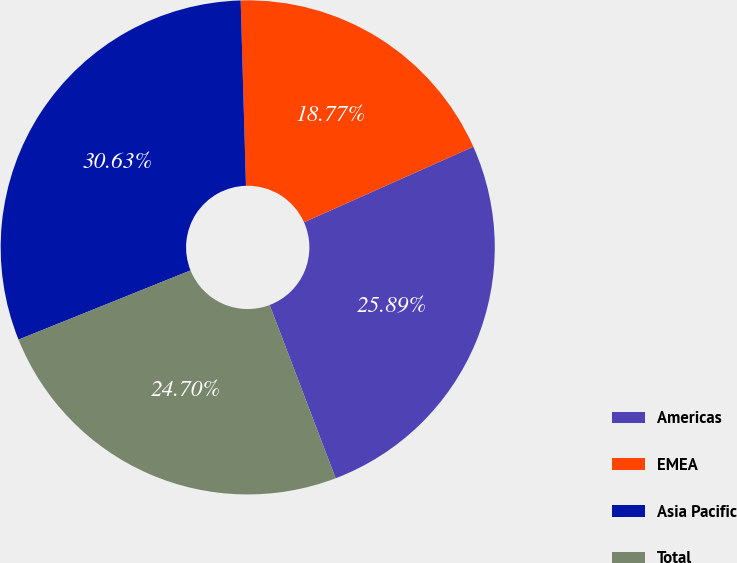Convert chart. <chart><loc_0><loc_0><loc_500><loc_500><pie_chart><fcel>Americas<fcel>EMEA<fcel>Asia Pacific<fcel>Total<nl><fcel>25.89%<fcel>18.77%<fcel>30.63%<fcel>24.7%<nl></chart> 